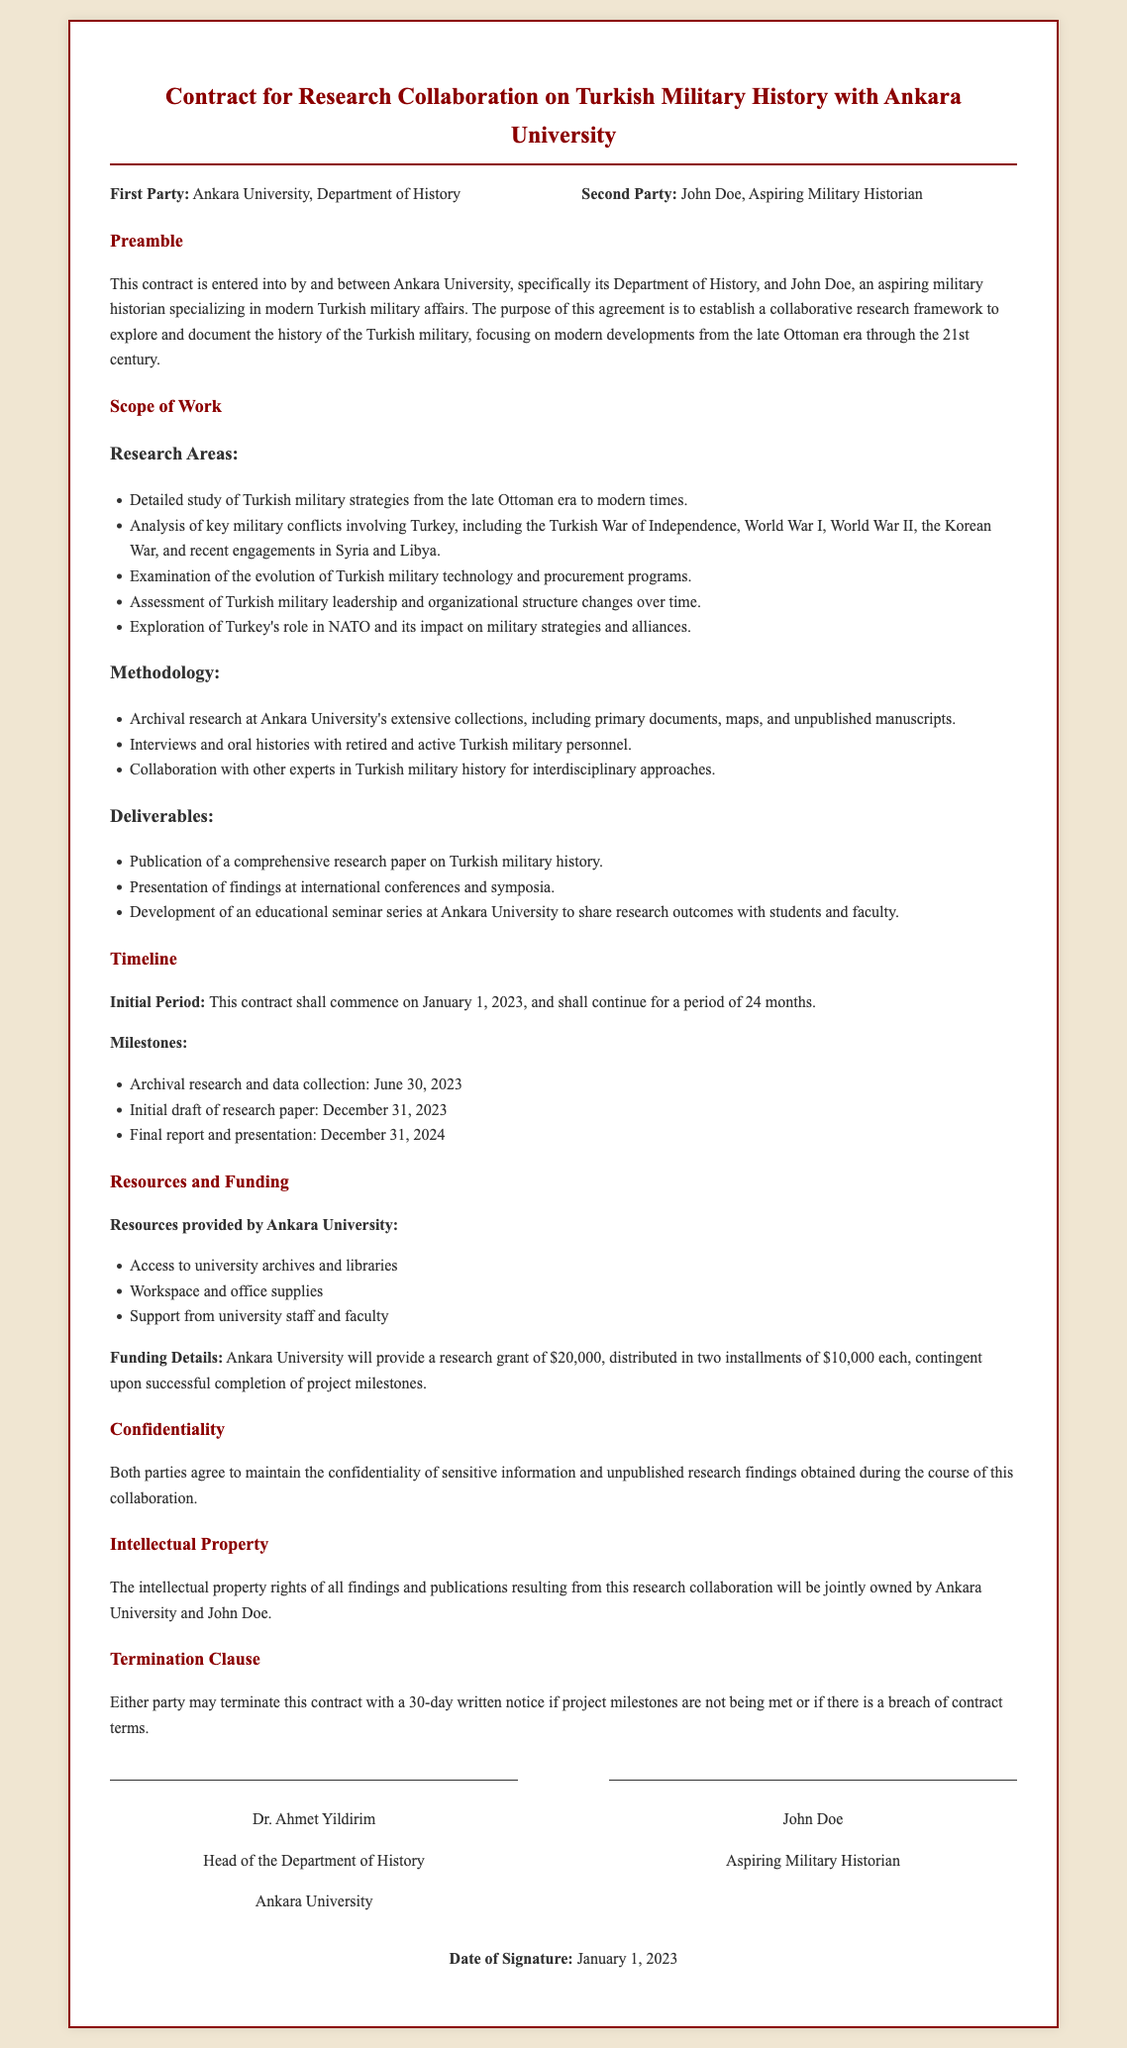What is the first party in the contract? The first party is specified as Ankara University, Department of History in the document.
Answer: Ankara University, Department of History What is the duration of the contract? The contract states it shall continue for a period of 24 months from the start date.
Answer: 24 months What is the total amount of research funding provided? The document specifies that Ankara University will provide a research grant totaling $20,000.
Answer: $20,000 When is the initial draft of the research paper due? The milestone indicates that the initial draft is due by December 31, 2023.
Answer: December 31, 2023 What kind of methodologies will be used in the research? The methodologies listed include archival research and interviews with military personnel.
Answer: Archival research and interviews What happens if either party breaches the contract? The document states that either party may terminate the contract with a 30-day written notice under such circumstances.
Answer: 30-day written notice Who is responsible for signing on behalf of Ankara University? The document indicates that the Head of the Department of History is the signatory on behalf of the university.
Answer: Dr. Ahmet Yildirim What key military conflict from World War I is mentioned in the research areas? The document refers to the Turkish War of Independence as a key conflict to be analyzed.
Answer: Turkish War of Independence What is the confidentiality agreement related to? The confidentiality section specifies that both parties will maintain the confidentiality of sensitive information and unpublished research findings.
Answer: Sensitive information and unpublished research findings 